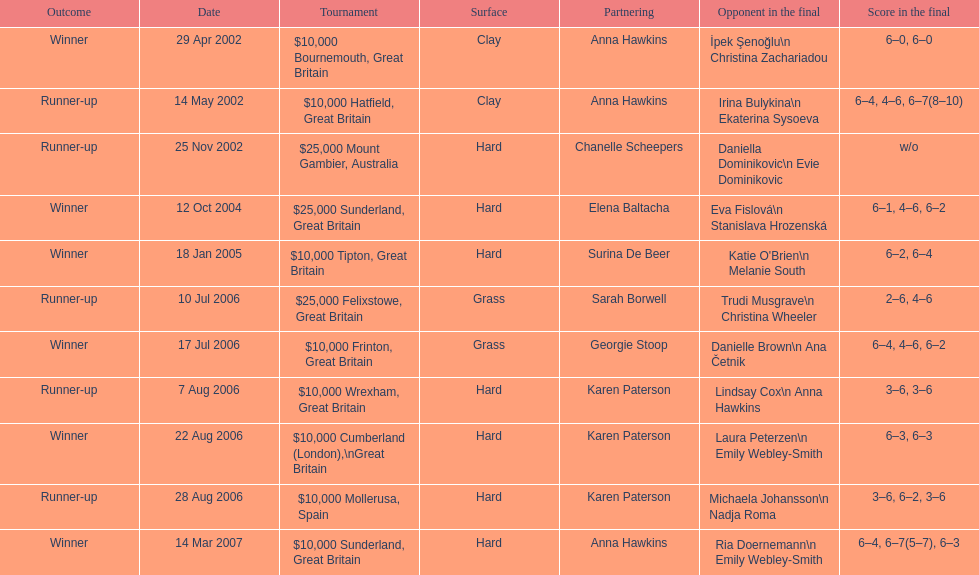How many tournaments has jane o'donoghue competed in? 11. 